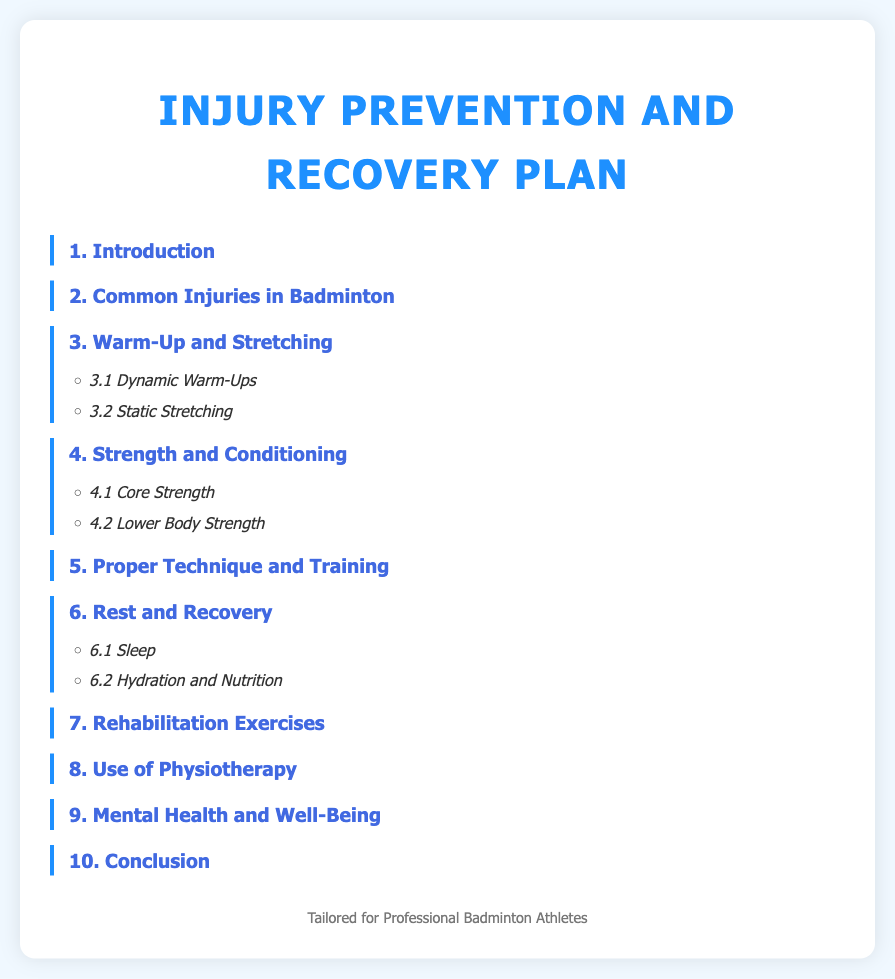What is the title of the document? The title of the document is the main heading displayed prominently at the top of the page.
Answer: Injury Prevention and Recovery Plan for Professional Badminton Athletes How many main sections are there in this document? The number of main sections is determined by counting the number of index items listed.
Answer: 10 What is one common injury mentioned in badminton? The document states common injuries in badminton but does not specify examples in the index.
Answer: Not specified What are the two types of warm-up methods listed? The types of warm-up methods can be found in the sub-sections under the warm-up heading.
Answer: Dynamic Warm-Ups, Static Stretching What does section 6 focus on? The title of section 6 reveals its focus area in the injury prevention and recovery plan.
Answer: Rest and Recovery Which area emphasizes physical conditioning? This area is indicated by key terms that suggest physical preparedness and strength enhancement.
Answer: Strength and Conditioning How many sub-sections are under 'Rest and Recovery'? This is derived by counting the sub-items listed under the 'Rest and Recovery' section in the index.
Answer: 2 What part of the document addresses mental health? The specific section dedicated to the mental aspect of athletes can be identified in the index.
Answer: 9. Mental Health and Well-Being What is mentioned as a part of rehabilitation? The title of the section indicates a focus on exercises aimed at recovery.
Answer: Rehabilitation Exercises 